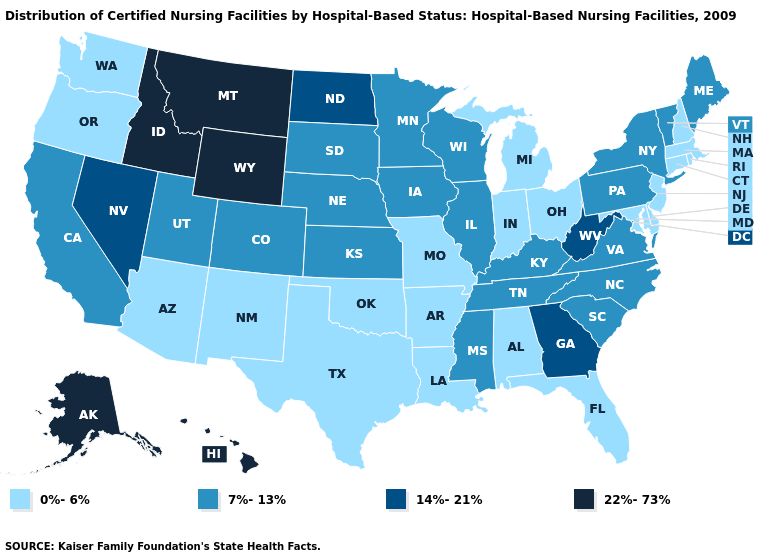Name the states that have a value in the range 7%-13%?
Be succinct. California, Colorado, Illinois, Iowa, Kansas, Kentucky, Maine, Minnesota, Mississippi, Nebraska, New York, North Carolina, Pennsylvania, South Carolina, South Dakota, Tennessee, Utah, Vermont, Virginia, Wisconsin. What is the highest value in the West ?
Answer briefly. 22%-73%. Does Oregon have the same value as Texas?
Concise answer only. Yes. What is the value of Missouri?
Concise answer only. 0%-6%. Which states have the lowest value in the Northeast?
Write a very short answer. Connecticut, Massachusetts, New Hampshire, New Jersey, Rhode Island. Does Massachusetts have the lowest value in the Northeast?
Quick response, please. Yes. What is the value of Michigan?
Be succinct. 0%-6%. What is the value of Connecticut?
Keep it brief. 0%-6%. Name the states that have a value in the range 0%-6%?
Keep it brief. Alabama, Arizona, Arkansas, Connecticut, Delaware, Florida, Indiana, Louisiana, Maryland, Massachusetts, Michigan, Missouri, New Hampshire, New Jersey, New Mexico, Ohio, Oklahoma, Oregon, Rhode Island, Texas, Washington. Does Virginia have a higher value than North Carolina?
Answer briefly. No. What is the lowest value in the USA?
Write a very short answer. 0%-6%. What is the value of New Hampshire?
Concise answer only. 0%-6%. Name the states that have a value in the range 0%-6%?
Be succinct. Alabama, Arizona, Arkansas, Connecticut, Delaware, Florida, Indiana, Louisiana, Maryland, Massachusetts, Michigan, Missouri, New Hampshire, New Jersey, New Mexico, Ohio, Oklahoma, Oregon, Rhode Island, Texas, Washington. Which states have the lowest value in the Northeast?
Short answer required. Connecticut, Massachusetts, New Hampshire, New Jersey, Rhode Island. What is the value of West Virginia?
Short answer required. 14%-21%. 